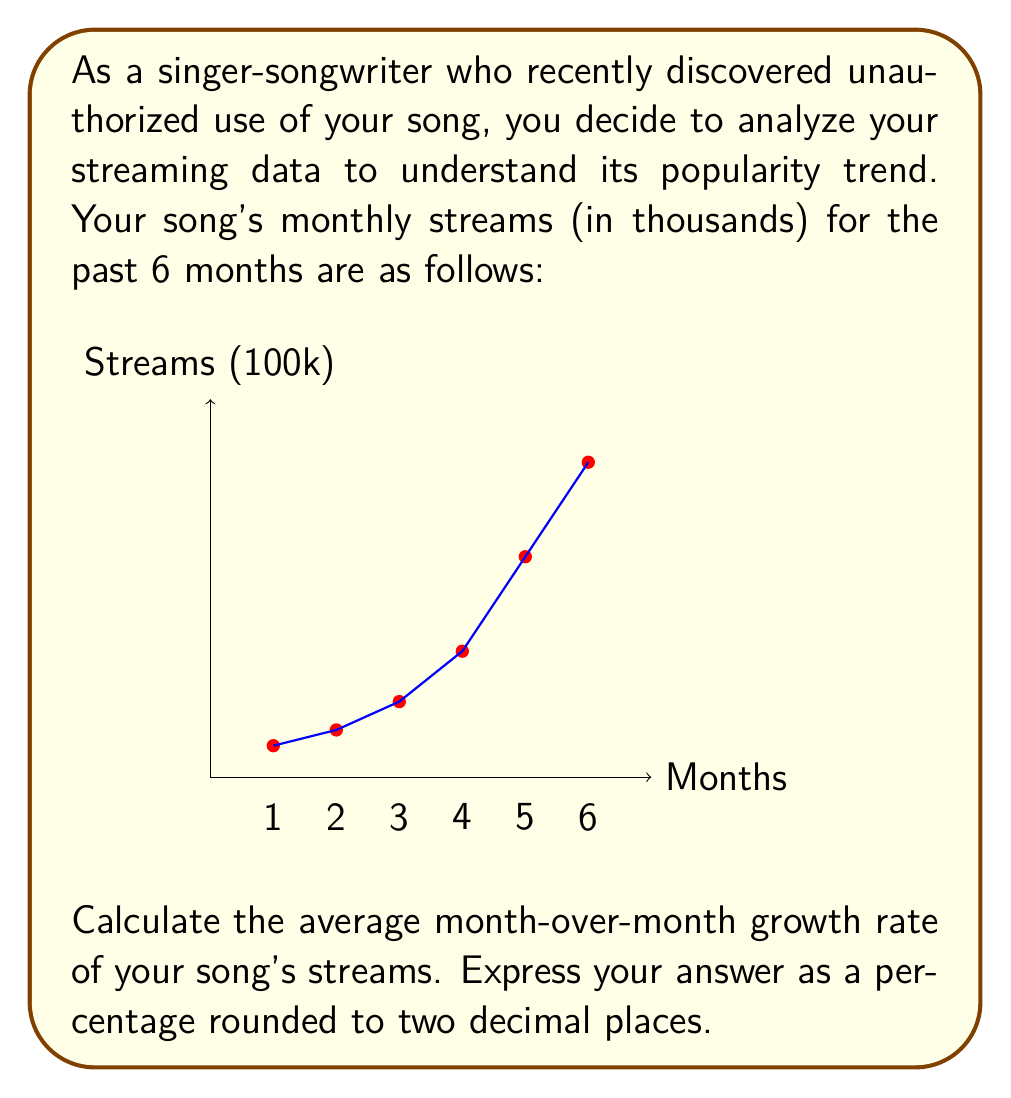Could you help me with this problem? To calculate the average month-over-month growth rate, we'll follow these steps:

1) Calculate the growth rate for each month:
   Growth rate = (Current month's streams - Previous month's streams) / Previous month's streams

   Month 2: $\frac{75 - 50}{50} = 0.5$ or 50%
   Month 3: $\frac{120 - 75}{75} = 0.6$ or 60%
   Month 4: $\frac{200 - 120}{120} = 0.6667$ or 66.67%
   Month 5: $\frac{350 - 200}{200} = 0.75$ or 75%
   Month 6: $\frac{500 - 350}{350} = 0.4286$ or 42.86%

2) Calculate the average of these growth rates:
   $\frac{0.5 + 0.6 + 0.6667 + 0.75 + 0.4286}{5} = 0.5891$

3) Convert to percentage and round to two decimal places:
   0.5891 * 100 = 58.91%

Therefore, the average month-over-month growth rate is 58.91%.
Answer: 58.91% 